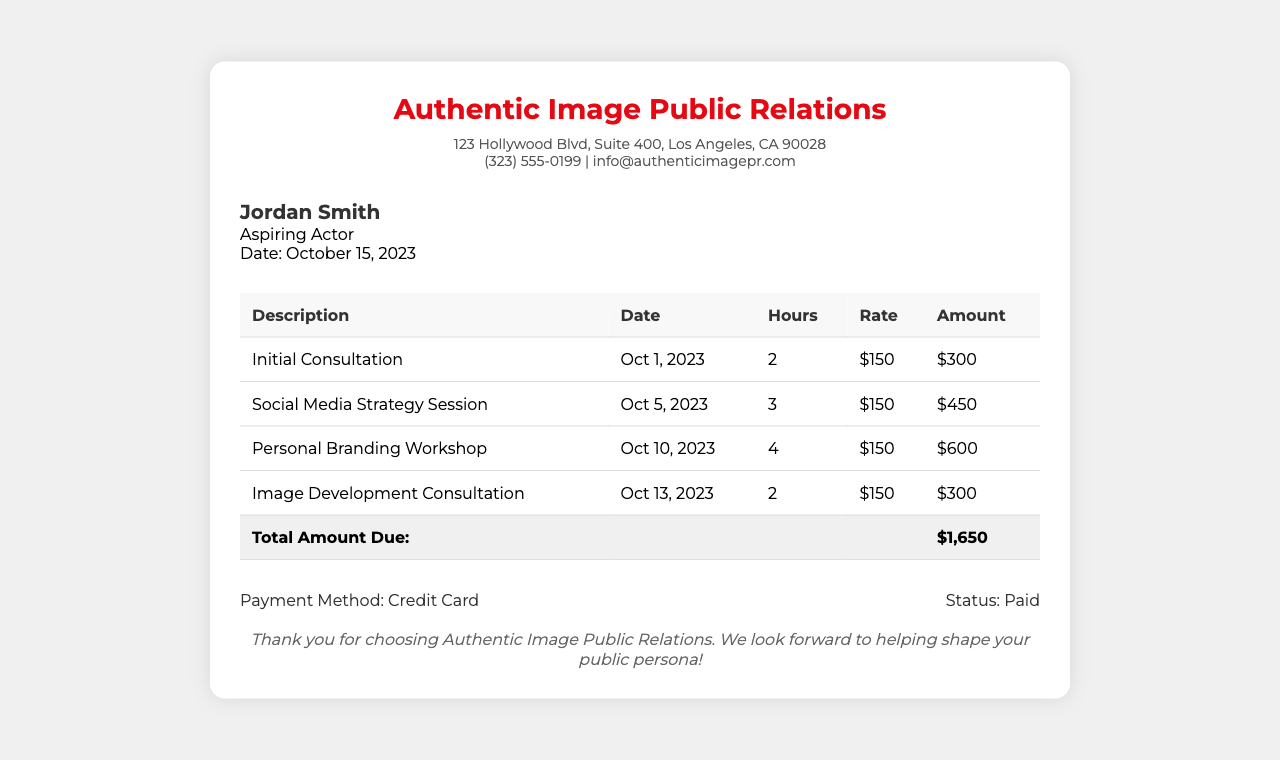What is the client's name? The client's name is clearly stated at the top of the receipt.
Answer: Jordan Smith What is the total amount due? The total amount is calculated from the services provided, showing the sum at the bottom of the services table.
Answer: $1,650 How many hours were spent on the Personal Branding Workshop? The document shows the hours for each service, specifically for the Personal Branding Workshop.
Answer: 4 What was the date of the Image Development Consultation? The date for each service is outlined in the services table, indicating when each service occurred.
Answer: Oct 13, 2023 What is the payment method used? The payment method is listed in the payment information section of the receipt.
Answer: Credit Card What is the hourly rate for the services? The rate is consistent across all services and is specified next to each entry in the services table.
Answer: $150 What type of receipt is this? This document is specifically a payment receipt for services rendered.
Answer: Actor Services Payment Receipt Which firm provided the consultation services? The firm providing the services is identified at the top of the receipt.
Answer: Authentic Image Public Relations How many sessions were conducted on Oct 5, 2023? The document specifies the services provided on that date, which is listed in the services table.
Answer: 1 